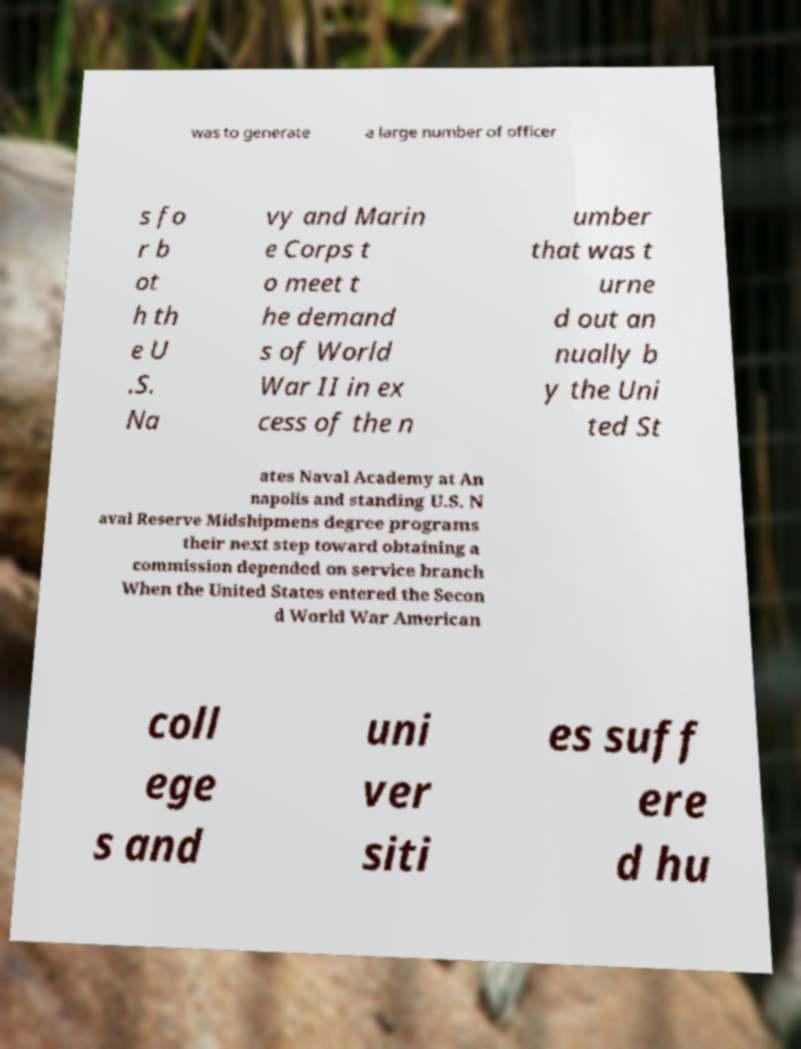Can you read and provide the text displayed in the image?This photo seems to have some interesting text. Can you extract and type it out for me? was to generate a large number of officer s fo r b ot h th e U .S. Na vy and Marin e Corps t o meet t he demand s of World War II in ex cess of the n umber that was t urne d out an nually b y the Uni ted St ates Naval Academy at An napolis and standing U.S. N aval Reserve Midshipmens degree programs their next step toward obtaining a commission depended on service branch When the United States entered the Secon d World War American coll ege s and uni ver siti es suff ere d hu 